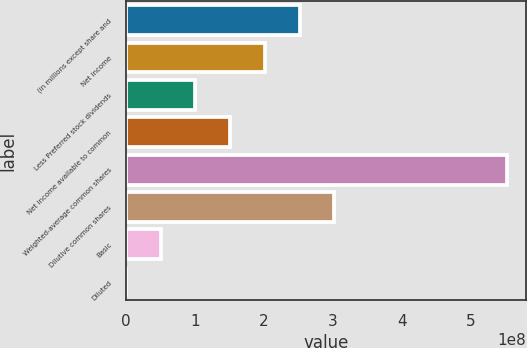Convert chart to OTSL. <chart><loc_0><loc_0><loc_500><loc_500><bar_chart><fcel>(in millions except share and<fcel>Net income<fcel>Less Preferred stock dividends<fcel>Net income available to common<fcel>Weighted-average common shares<fcel>Dilutive common shares<fcel>Basic<fcel>Diluted<nl><fcel>2.51843e+08<fcel>2.01474e+08<fcel>1.00737e+08<fcel>1.51106e+08<fcel>5.52526e+08<fcel>3.02211e+08<fcel>5.03685e+07<fcel>3.25<nl></chart> 